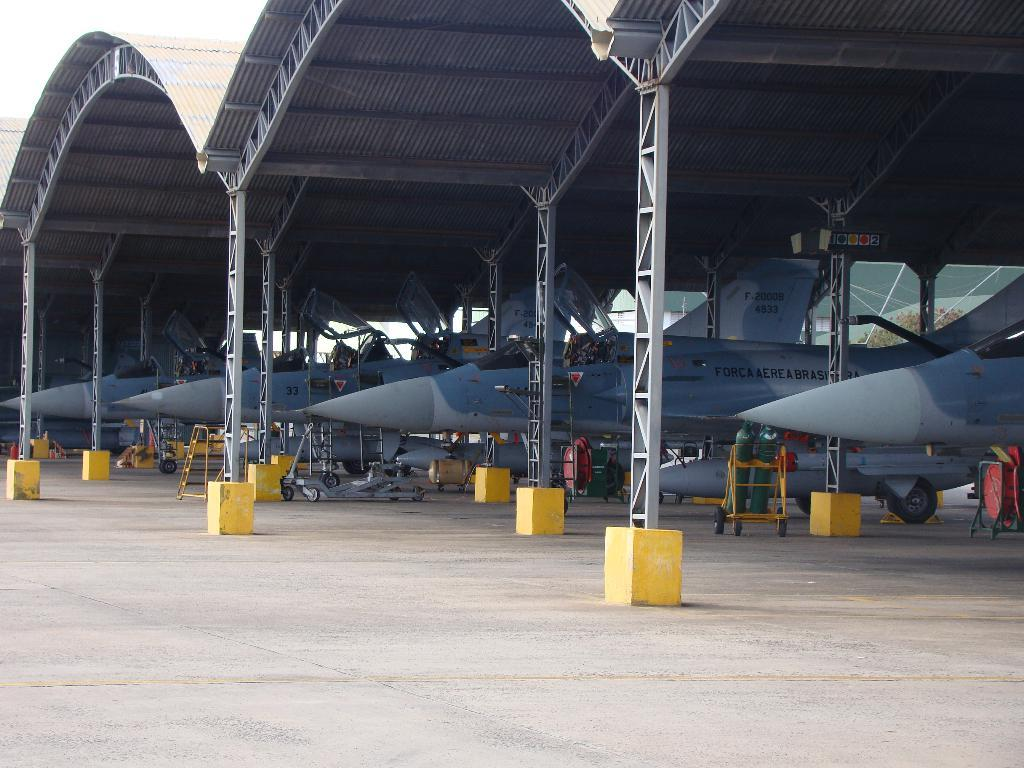<image>
Describe the image concisely. Airplanes from the Brazilian air force are parked in a hangar. 